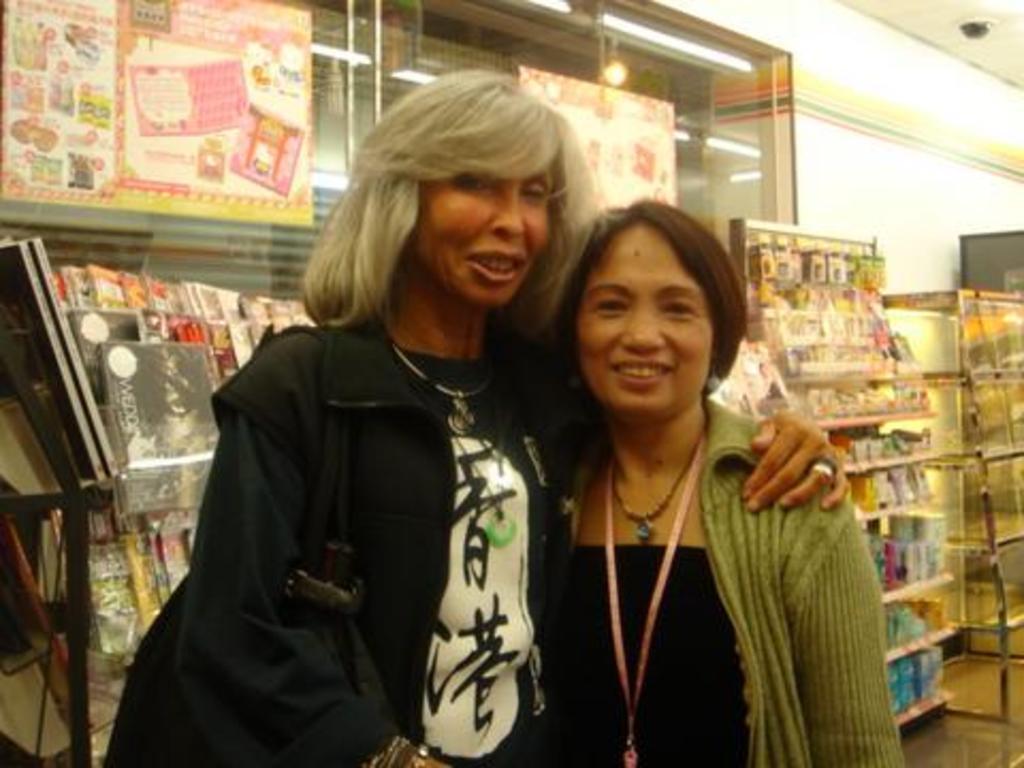Describe this image in one or two sentences. In this image there are two women standing with a smile on their face, behind them there are magazines and a few other objects in the aisles. 